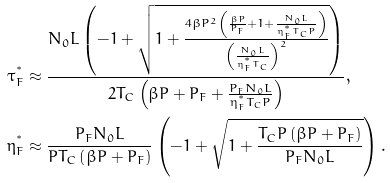<formula> <loc_0><loc_0><loc_500><loc_500>\tau ^ { ^ { * } } _ { F } & \approx \frac { N _ { 0 } L \left ( - 1 + \sqrt { 1 + \frac { 4 \beta P ^ { 2 } \left ( \frac { \beta P } { P _ { F } } + 1 + \frac { N _ { 0 } L } { \eta _ { F } ^ { ^ { * } } T _ { C } P } \right ) } { \left ( \frac { N _ { 0 } L } { \eta _ { F } ^ { ^ { * } } T _ { C } } \right ) ^ { 2 } } } \right ) } { 2 T _ { C } \left ( \beta P + P _ { F } + \frac { P _ { F } N _ { 0 } L } { \eta _ { F } ^ { ^ { * } } T _ { C } P } \right ) } , \\ \eta _ { F } ^ { ^ { * } } & \approx \frac { P _ { F } N _ { 0 } L } { P T _ { C } \left ( \beta P + P _ { F } \right ) } \left ( - 1 + \sqrt { 1 + \frac { T _ { C } P \left ( \beta P + P _ { F } \right ) } { P _ { F } N _ { 0 } L } } \right ) .</formula> 